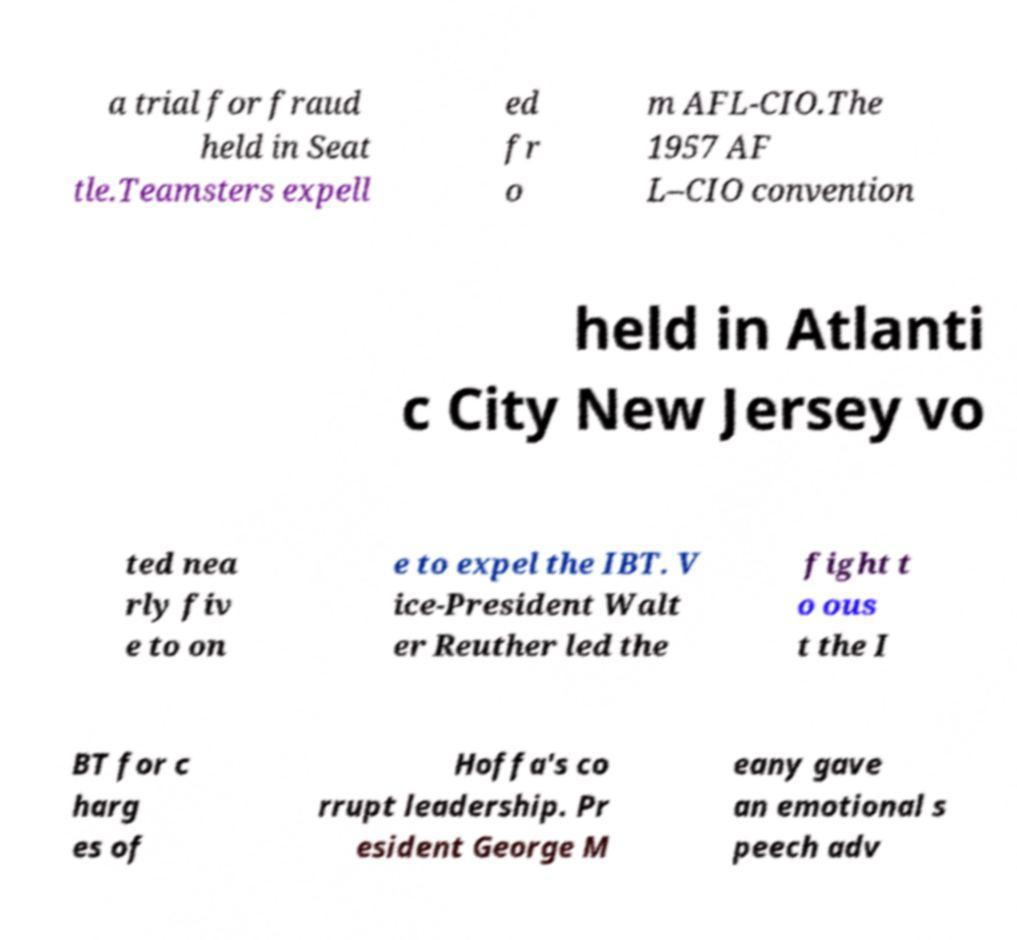I need the written content from this picture converted into text. Can you do that? a trial for fraud held in Seat tle.Teamsters expell ed fr o m AFL-CIO.The 1957 AF L–CIO convention held in Atlanti c City New Jersey vo ted nea rly fiv e to on e to expel the IBT. V ice-President Walt er Reuther led the fight t o ous t the I BT for c harg es of Hoffa's co rrupt leadership. Pr esident George M eany gave an emotional s peech adv 